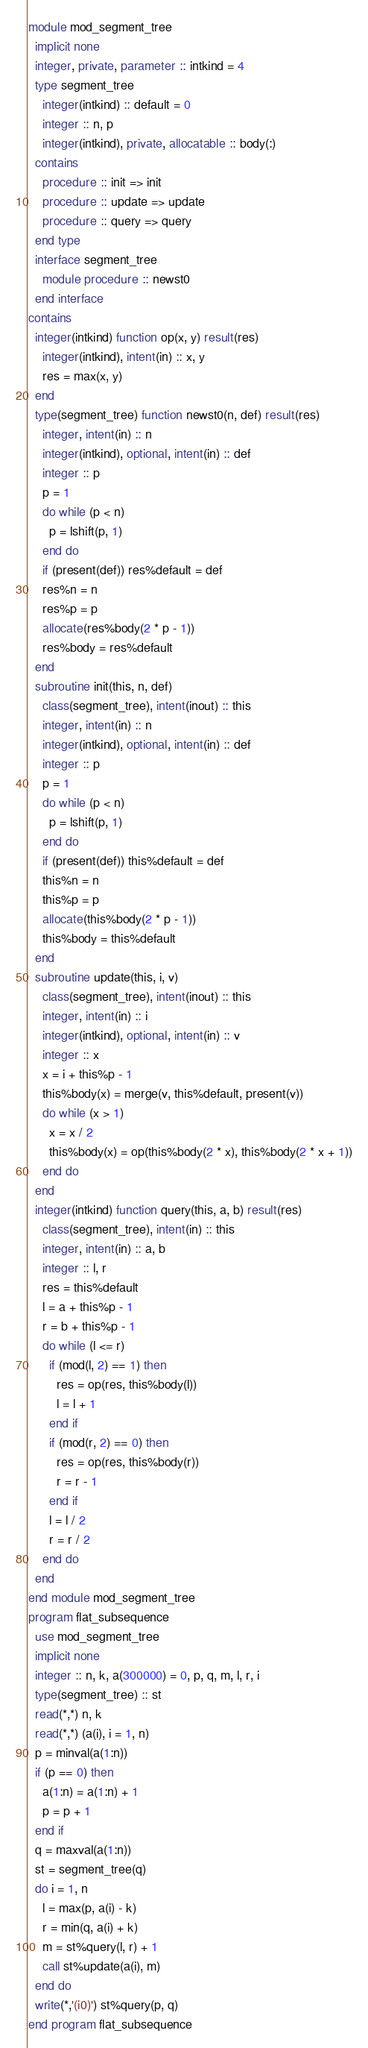Convert code to text. <code><loc_0><loc_0><loc_500><loc_500><_FORTRAN_>module mod_segment_tree
  implicit none
  integer, private, parameter :: intkind = 4
  type segment_tree
    integer(intkind) :: default = 0
    integer :: n, p
    integer(intkind), private, allocatable :: body(:)
  contains
    procedure :: init => init
    procedure :: update => update
    procedure :: query => query
  end type
  interface segment_tree
    module procedure :: newst0
  end interface
contains
  integer(intkind) function op(x, y) result(res)
    integer(intkind), intent(in) :: x, y
    res = max(x, y)
  end
  type(segment_tree) function newst0(n, def) result(res)
    integer, intent(in) :: n
    integer(intkind), optional, intent(in) :: def
    integer :: p
    p = 1
    do while (p < n)
      p = lshift(p, 1)
    end do
    if (present(def)) res%default = def
    res%n = n
    res%p = p
    allocate(res%body(2 * p - 1))
    res%body = res%default
  end
  subroutine init(this, n, def)
    class(segment_tree), intent(inout) :: this
    integer, intent(in) :: n
    integer(intkind), optional, intent(in) :: def
    integer :: p
    p = 1
    do while (p < n)
      p = lshift(p, 1)
    end do
    if (present(def)) this%default = def
    this%n = n
    this%p = p
    allocate(this%body(2 * p - 1))
    this%body = this%default
  end
  subroutine update(this, i, v)
    class(segment_tree), intent(inout) :: this
    integer, intent(in) :: i
    integer(intkind), optional, intent(in) :: v
    integer :: x
    x = i + this%p - 1
    this%body(x) = merge(v, this%default, present(v))
    do while (x > 1)
      x = x / 2
      this%body(x) = op(this%body(2 * x), this%body(2 * x + 1))
    end do
  end
  integer(intkind) function query(this, a, b) result(res)
    class(segment_tree), intent(in) :: this
    integer, intent(in) :: a, b
    integer :: l, r
    res = this%default
    l = a + this%p - 1
    r = b + this%p - 1
    do while (l <= r)
      if (mod(l, 2) == 1) then
        res = op(res, this%body(l))
        l = l + 1
      end if
      if (mod(r, 2) == 0) then
        res = op(res, this%body(r))
        r = r - 1
      end if
      l = l / 2
      r = r / 2
    end do
  end
end module mod_segment_tree
program flat_subsequence
  use mod_segment_tree
  implicit none
  integer :: n, k, a(300000) = 0, p, q, m, l, r, i
  type(segment_tree) :: st
  read(*,*) n, k
  read(*,*) (a(i), i = 1, n)
  p = minval(a(1:n))
  if (p == 0) then
    a(1:n) = a(1:n) + 1
    p = p + 1
  end if
  q = maxval(a(1:n))
  st = segment_tree(q)
  do i = 1, n
    l = max(p, a(i) - k)
    r = min(q, a(i) + k)
    m = st%query(l, r) + 1
    call st%update(a(i), m)
  end do
  write(*,'(i0)') st%query(p, q)
end program flat_subsequence</code> 